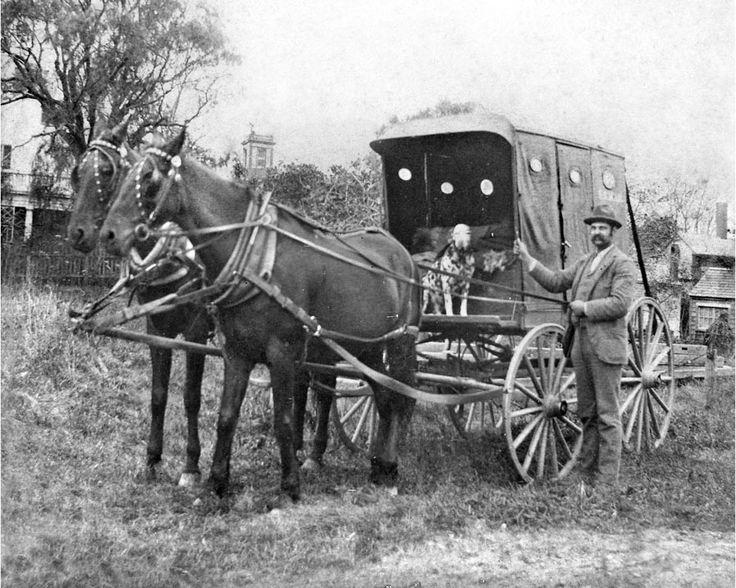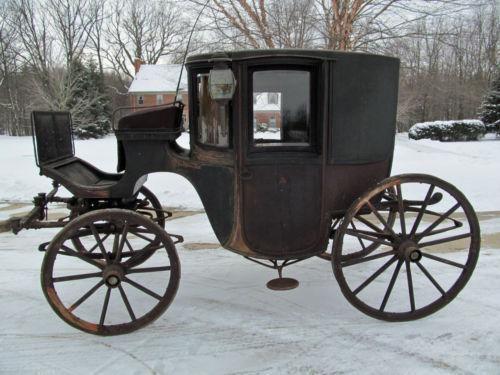The first image is the image on the left, the second image is the image on the right. Examine the images to the left and right. Is the description "An image shows a left-facing horse-drawn cart with only two wheels." accurate? Answer yes or no. No. 